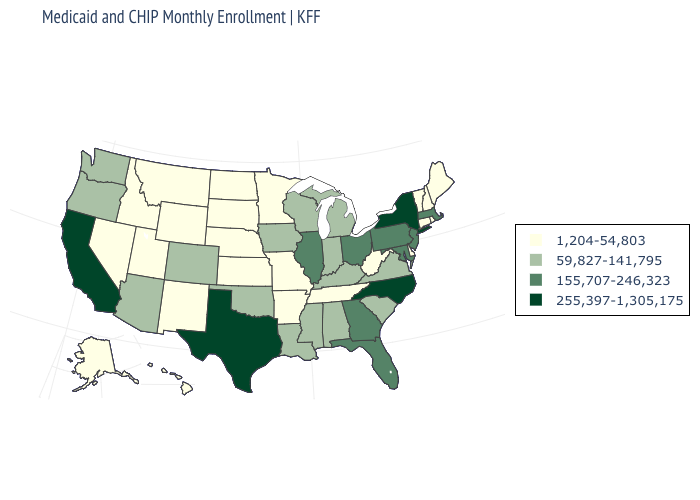What is the value of New Hampshire?
Keep it brief. 1,204-54,803. What is the value of Kansas?
Be succinct. 1,204-54,803. Which states have the highest value in the USA?
Give a very brief answer. California, New York, North Carolina, Texas. What is the lowest value in the Northeast?
Write a very short answer. 1,204-54,803. What is the highest value in the South ?
Concise answer only. 255,397-1,305,175. What is the value of New Hampshire?
Quick response, please. 1,204-54,803. Does the first symbol in the legend represent the smallest category?
Keep it brief. Yes. What is the highest value in states that border New Hampshire?
Answer briefly. 155,707-246,323. What is the value of North Carolina?
Quick response, please. 255,397-1,305,175. Does Michigan have a higher value than Nebraska?
Be succinct. Yes. Name the states that have a value in the range 255,397-1,305,175?
Answer briefly. California, New York, North Carolina, Texas. What is the value of California?
Quick response, please. 255,397-1,305,175. What is the highest value in the MidWest ?
Short answer required. 155,707-246,323. What is the value of New Hampshire?
Answer briefly. 1,204-54,803. Does the map have missing data?
Short answer required. No. 